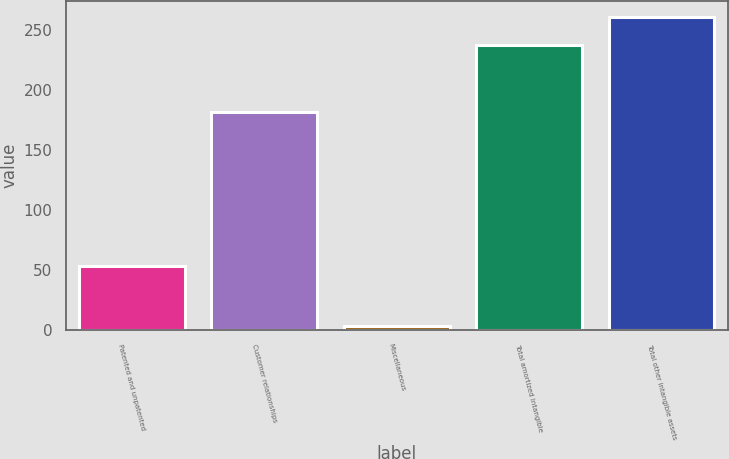Convert chart. <chart><loc_0><loc_0><loc_500><loc_500><bar_chart><fcel>Patented and unpatented<fcel>Customer relationships<fcel>Miscellaneous<fcel>Total amortized intangible<fcel>Total other intangible assets<nl><fcel>52.9<fcel>181<fcel>3.2<fcel>237.1<fcel>260.49<nl></chart> 